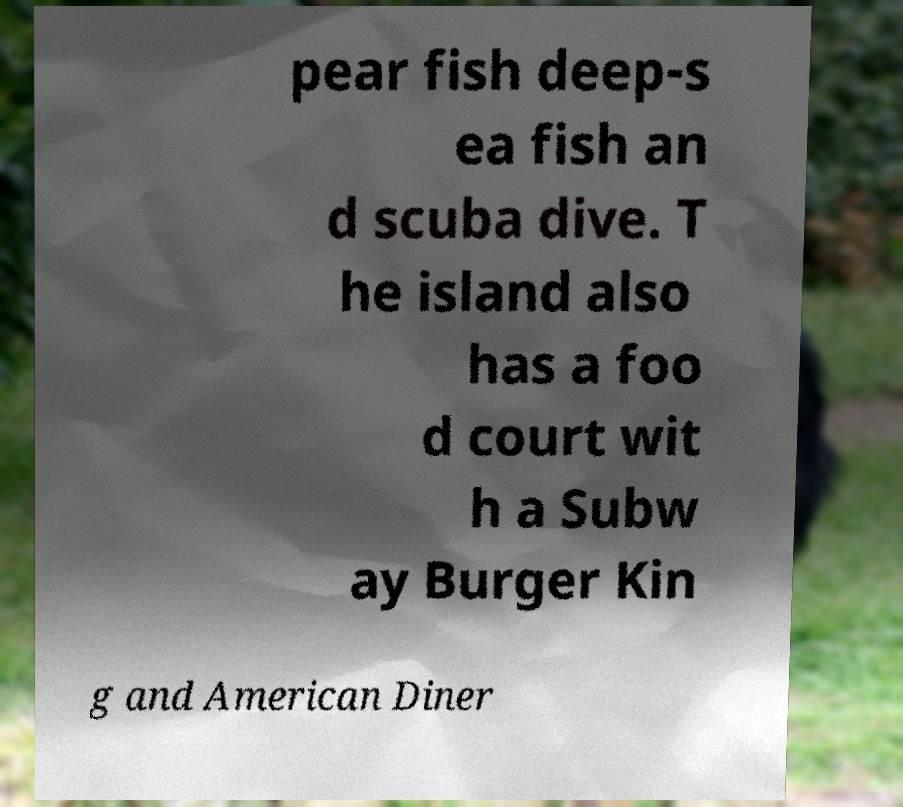Could you extract and type out the text from this image? pear fish deep-s ea fish an d scuba dive. T he island also has a foo d court wit h a Subw ay Burger Kin g and American Diner 